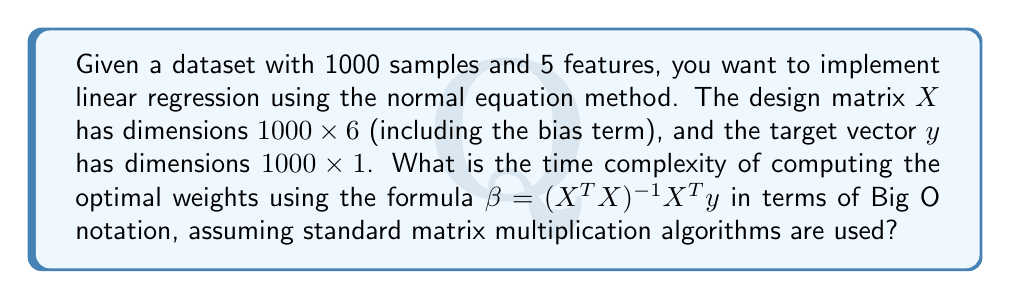Teach me how to tackle this problem. To determine the time complexity, let's break down the steps involved in computing $\beta = (X^T X)^{-1} X^T y$:

1. Computing $X^T X$:
   - X has dimensions 1000 x 6
   - $X^T$ has dimensions 6 x 1000
   - Resulting matrix has dimensions 6 x 6
   - Time complexity: $O(1000 \cdot 6 \cdot 6) = O(36000) = O(1)$

2. Computing $(X^T X)^{-1}$:
   - Inverting a 6 x 6 matrix
   - Time complexity: $O(6^3) = O(216) = O(1)$

3. Computing $X^T y$:
   - $X^T$ has dimensions 6 x 1000
   - y has dimensions 1000 x 1
   - Resulting vector has dimensions 6 x 1
   - Time complexity: $O(6 \cdot 1000 \cdot 1) = O(6000) = O(1)$

4. Multiplying $(X^T X)^{-1}$ with $X^T y$:
   - $(X^T X)^{-1}$ has dimensions 6 x 6
   - $X^T y$ has dimensions 6 x 1
   - Time complexity: $O(6 \cdot 6 \cdot 1) = O(36) = O(1)$

The overall time complexity is the maximum of these steps, which is $O(1)$ in this case. However, it's important to note that this is because the number of features (6) is considered constant. In general, for n samples and p features, the time complexity would be $O(np^2 + p^3)$.
Answer: $O(1)$ 